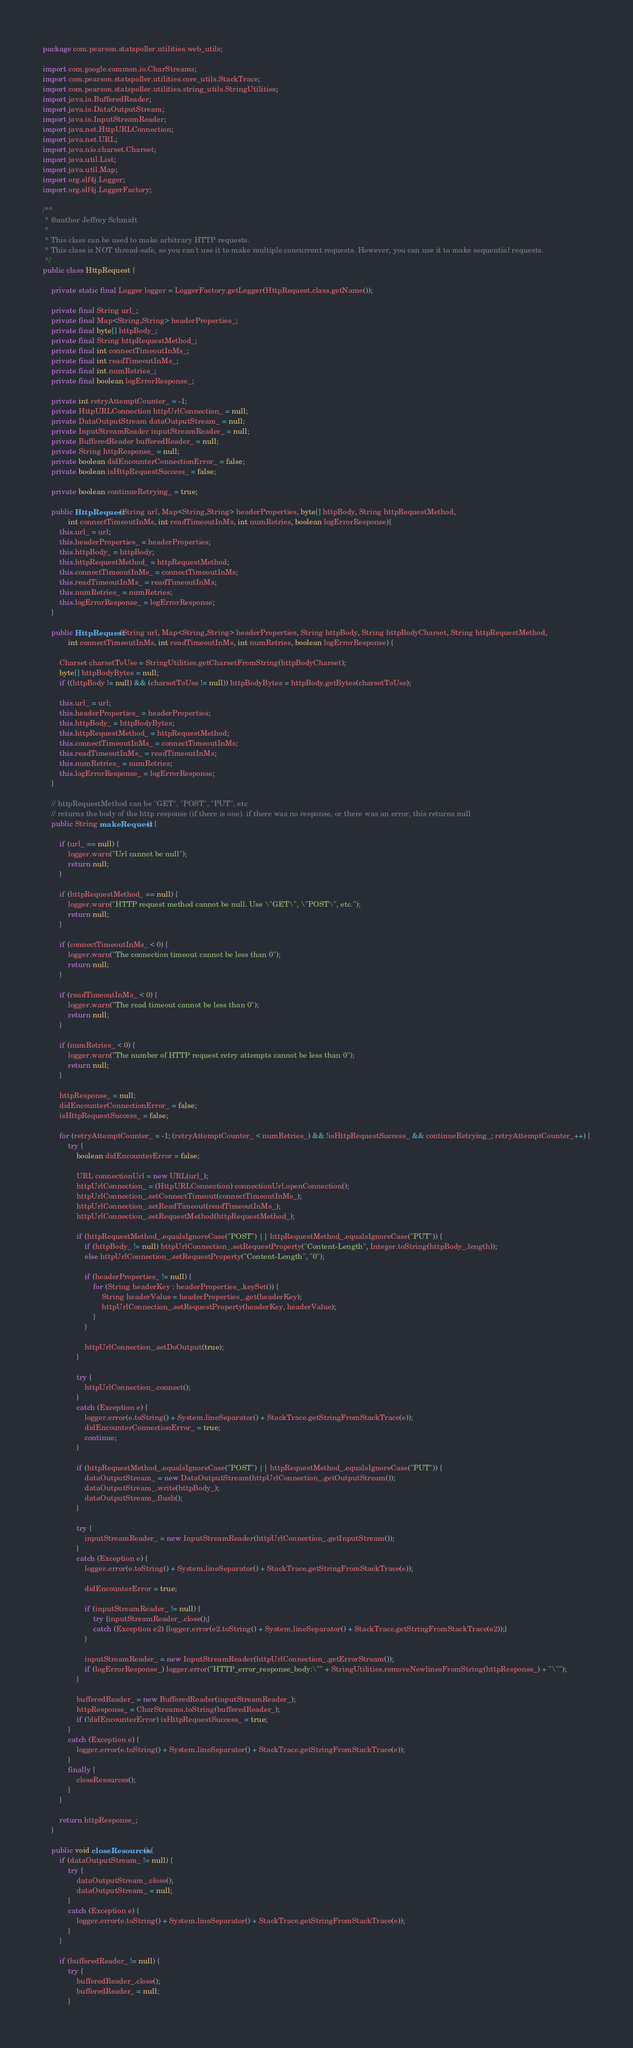<code> <loc_0><loc_0><loc_500><loc_500><_Java_>package com.pearson.statspoller.utilities.web_utils;

import com.google.common.io.CharStreams;
import com.pearson.statspoller.utilities.core_utils.StackTrace;
import com.pearson.statspoller.utilities.string_utils.StringUtilities;
import java.io.BufferedReader;
import java.io.DataOutputStream;
import java.io.InputStreamReader;
import java.net.HttpURLConnection;
import java.net.URL;
import java.nio.charset.Charset;
import java.util.List;
import java.util.Map;
import org.slf4j.Logger;
import org.slf4j.LoggerFactory;

/**
 * @author Jeffrey Schmidt
 * 
 * This class can be used to make arbitrary HTTP requests. 
 * This class is NOT thread-safe, so you can't use it to make multiple concurrent requests. However, you can use it to make sequential requests.
 */
public class HttpRequest {
    
    private static final Logger logger = LoggerFactory.getLogger(HttpRequest.class.getName());

    private final String url_;
    private final Map<String,String> headerProperties_;
    private final byte[] httpBody_;
    private final String httpRequestMethod_;
    private final int connectTimeoutInMs_;
    private final int readTimeoutInMs_;
    private final int numRetries_;
    private final boolean logErrorResponse_;
    
    private int retryAttemptCounter_ = -1;
    private HttpURLConnection httpUrlConnection_ = null;
    private DataOutputStream dataOutputStream_ = null;
    private InputStreamReader inputStreamReader_ = null;
    private BufferedReader bufferedReader_ = null;
    private String httpResponse_ = null;
    private boolean didEncounterConnectionError_ = false;
    private boolean isHttpRequestSuccess_ = false;
    
    private boolean continueRetrying_ = true;
    
    public HttpRequest(String url, Map<String,String> headerProperties, byte[] httpBody, String httpRequestMethod, 
            int connectTimeoutInMs, int readTimeoutInMs, int numRetries, boolean logErrorResponse){
        this.url_ = url;
        this.headerProperties_ = headerProperties;
        this.httpBody_ = httpBody;
        this.httpRequestMethod_ = httpRequestMethod;
        this.connectTimeoutInMs_ = connectTimeoutInMs;
        this.readTimeoutInMs_ = readTimeoutInMs;
        this.numRetries_ = numRetries;
        this.logErrorResponse_ = logErrorResponse;
    }
    
    public HttpRequest(String url, Map<String,String> headerProperties, String httpBody, String httpBodyCharset, String httpRequestMethod, 
            int connectTimeoutInMs, int readTimeoutInMs, int numRetries, boolean logErrorResponse) {
        
        Charset charsetToUse = StringUtilities.getCharsetFromString(httpBodyCharset);
        byte[] httpBodyBytes = null;
        if ((httpBody != null) && (charsetToUse != null)) httpBodyBytes = httpBody.getBytes(charsetToUse);
        
        this.url_ = url;
        this.headerProperties_ = headerProperties;
        this.httpBody_ = httpBodyBytes;
        this.httpRequestMethod_ = httpRequestMethod;
        this.connectTimeoutInMs_ = connectTimeoutInMs;
        this.readTimeoutInMs_ = readTimeoutInMs;
        this.numRetries_ = numRetries;
        this.logErrorResponse_ = logErrorResponse;
    }
            
    // httpRequestMethod can be "GET", "POST", "PUT", etc
    // returns the body of the http response (if there is one). if there was no response, or there was an error, this returns null
    public String makeRequest() {
        
        if (url_ == null) {
            logger.warn("Url cannot be null");
            return null;
        }
        
        if (httpRequestMethod_ == null) {
            logger.warn("HTTP request method cannot be null. Use \"GET\", \"POST\", etc.");
            return null;
        }
        
        if (connectTimeoutInMs_ < 0) {
            logger.warn("The connection timeout cannot be less than 0");
            return null;
        }
        
        if (readTimeoutInMs_ < 0) {
            logger.warn("The read timeout cannot be less than 0");
            return null;
        }
        
        if (numRetries_ < 0) {
            logger.warn("The number of HTTP request retry attempts cannot be less than 0");
            return null;
        }
        
        httpResponse_ = null;
        didEncounterConnectionError_ = false;
        isHttpRequestSuccess_ = false;
        
        for (retryAttemptCounter_ = -1; (retryAttemptCounter_ < numRetries_) && !isHttpRequestSuccess_ && continueRetrying_; retryAttemptCounter_++) {
            try {
                boolean didEncounterError = false;
                
                URL connectionUrl = new URL(url_);
                httpUrlConnection_ = (HttpURLConnection) connectionUrl.openConnection();
                httpUrlConnection_.setConnectTimeout(connectTimeoutInMs_);
                httpUrlConnection_.setReadTimeout(readTimeoutInMs_);
                httpUrlConnection_.setRequestMethod(httpRequestMethod_);
                
                if (httpRequestMethod_.equalsIgnoreCase("POST") || httpRequestMethod_.equalsIgnoreCase("PUT")) {
                    if (httpBody_ != null) httpUrlConnection_.setRequestProperty("Content-Length", Integer.toString(httpBody_.length));
                    else httpUrlConnection_.setRequestProperty("Content-Length", "0");

                    if (headerProperties_ != null) {
                        for (String headerKey : headerProperties_.keySet()) {
                            String headerValue = headerProperties_.get(headerKey);
                            httpUrlConnection_.setRequestProperty(headerKey, headerValue);
                        }
                    }
                    
                    httpUrlConnection_.setDoOutput(true);
                }
                
                try {
                    httpUrlConnection_.connect();
                }
                catch (Exception e) {
                    logger.error(e.toString() + System.lineSeparator() + StackTrace.getStringFromStackTrace(e));
                    didEncounterConnectionError_ = true;
                    continue;
                }
                
                if (httpRequestMethod_.equalsIgnoreCase("POST") || httpRequestMethod_.equalsIgnoreCase("PUT")) {
                    dataOutputStream_ = new DataOutputStream(httpUrlConnection_.getOutputStream());
                    dataOutputStream_.write(httpBody_);
                    dataOutputStream_.flush();
                }

                try {
                    inputStreamReader_ = new InputStreamReader(httpUrlConnection_.getInputStream());
                }
                catch (Exception e) {
                    logger.error(e.toString() + System.lineSeparator() + StackTrace.getStringFromStackTrace(e));
                    
                    didEncounterError = true;
                    
                    if (inputStreamReader_ != null) {
                        try {inputStreamReader_.close();} 
                        catch (Exception e2) {logger.error(e2.toString() + System.lineSeparator() + StackTrace.getStringFromStackTrace(e2));}
                    }
                
                    inputStreamReader_ = new InputStreamReader(httpUrlConnection_.getErrorStream());
                    if (logErrorResponse_) logger.error("HTTP_error_response_body:\"" + StringUtilities.removeNewlinesFromString(httpResponse_) + "\"");
                }
                
                bufferedReader_ = new BufferedReader(inputStreamReader_);
                httpResponse_ = CharStreams.toString(bufferedReader_);
                if (!didEncounterError) isHttpRequestSuccess_ = true;
            }
            catch (Exception e) {
                logger.error(e.toString() + System.lineSeparator() + StackTrace.getStringFromStackTrace(e));
            }
            finally {
                closeResources();
            }
        }
        
        return httpResponse_;
    }
    
    public void closeResources() {
        if (dataOutputStream_ != null) {
            try {
                dataOutputStream_.close();
                dataOutputStream_ = null;
            } 
            catch (Exception e) {
                logger.error(e.toString() + System.lineSeparator() + StackTrace.getStringFromStackTrace(e));
            }
        }

        if (bufferedReader_ != null) {
            try {
                bufferedReader_.close();
                bufferedReader_ = null;
            } </code> 